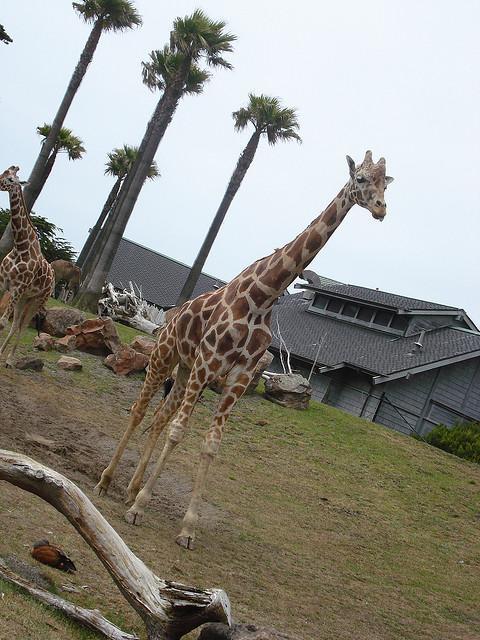How many windows are in the top of the building?
Give a very brief answer. 6. How many giraffes are in the photo?
Give a very brief answer. 2. 